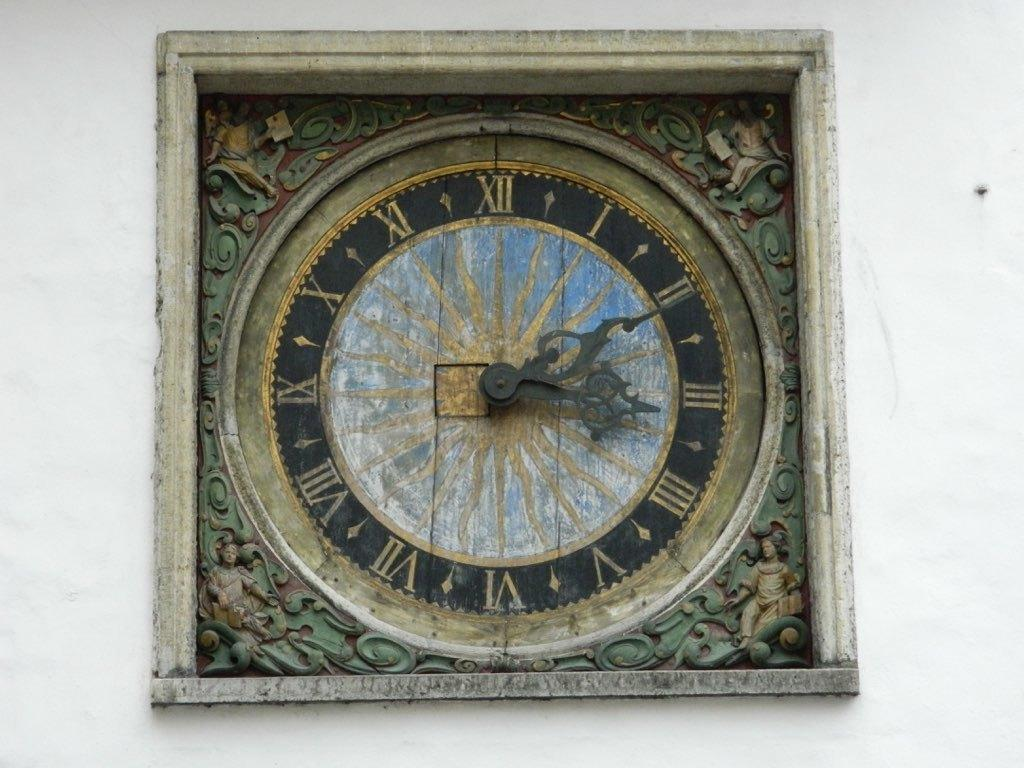Provide a one-sentence caption for the provided image. A very old clock says that it is 11 minutes past three o'clock. 